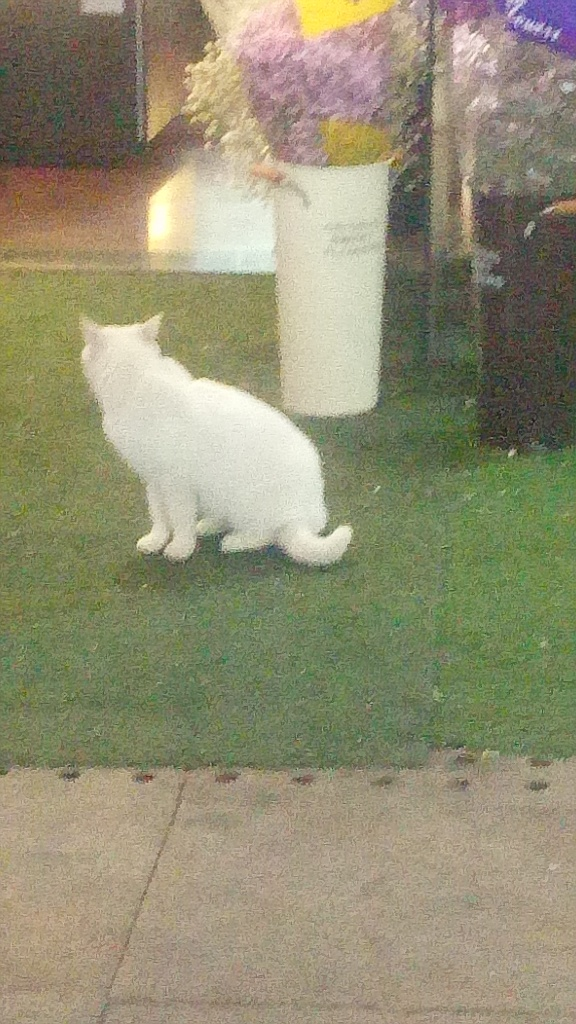Can you describe the overall mood or atmosphere depicted in this image? The overall atmosphere of the image seems serene and quiet, possibly depicting an evening or night scene where a cat is out exploring its surroundings, with a soft focus adding to the tranquility. Why might the cat be positioned in this particular stance? The cat's posture, with its body low to the ground and its attention directed ahead, suggests that it might be cautiously observing something of interest or preparing to pounce, common behaviors in cats when they are in a curious or hunting mode. 